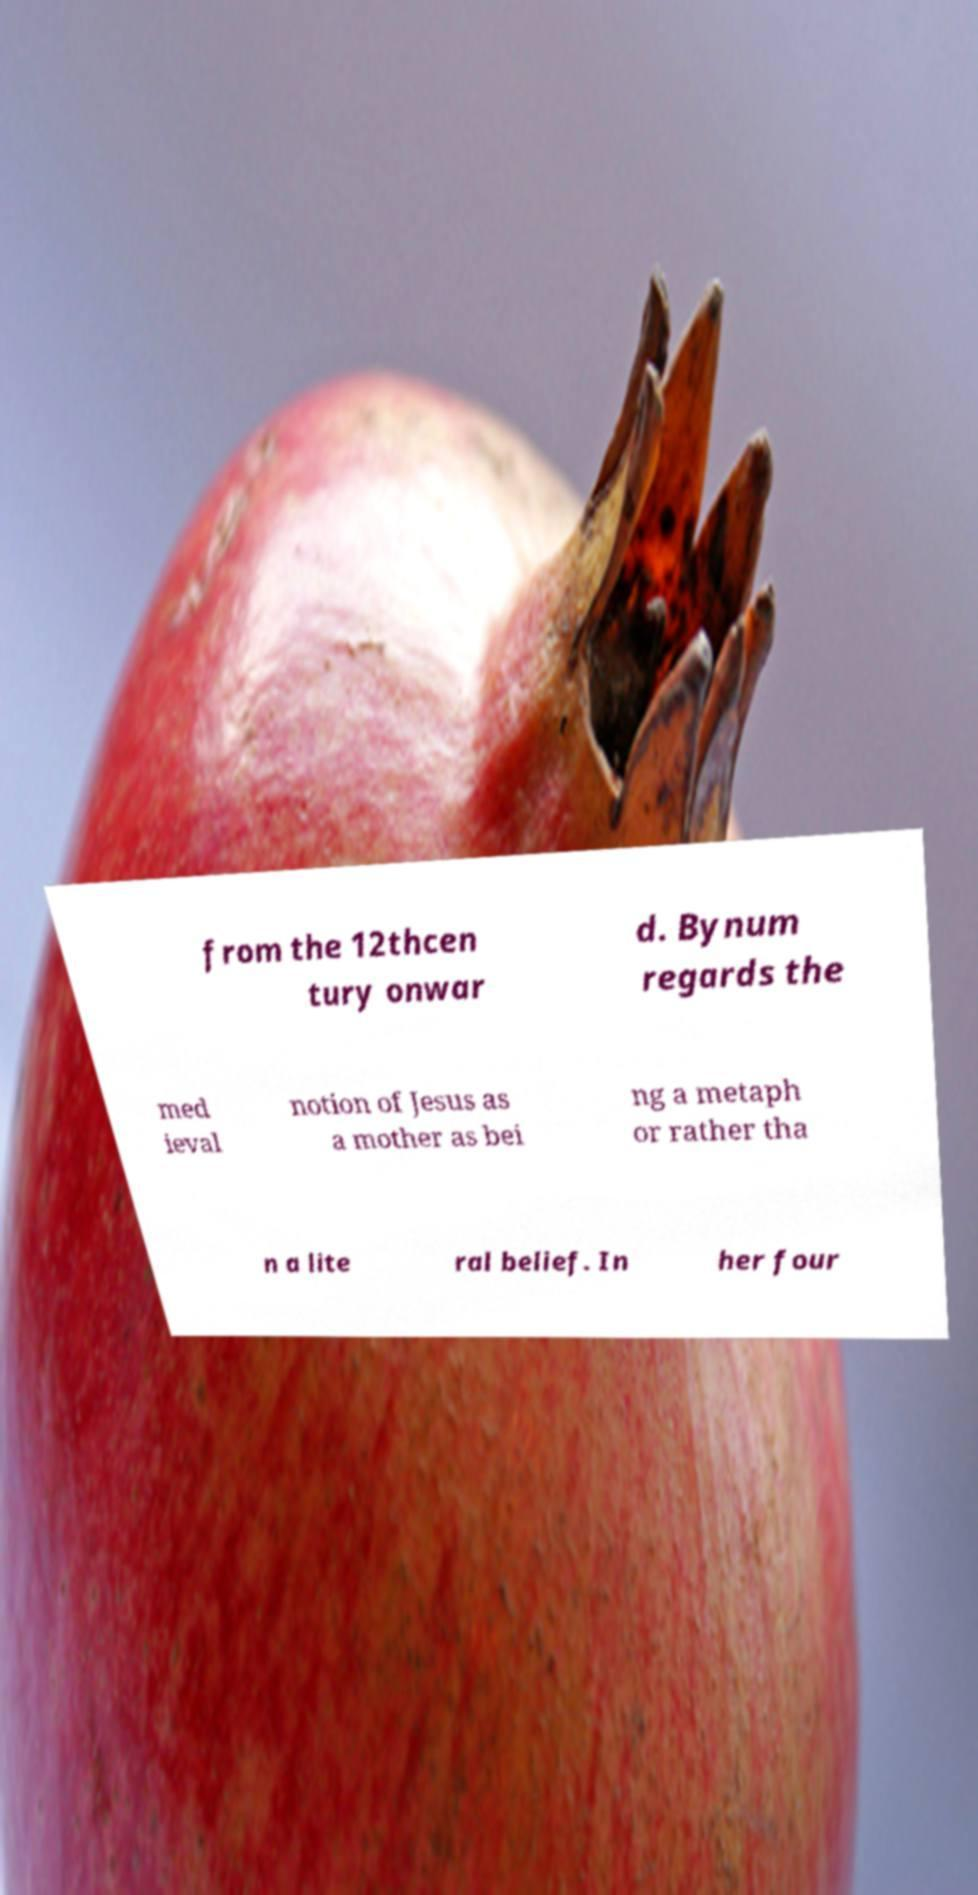There's text embedded in this image that I need extracted. Can you transcribe it verbatim? from the 12thcen tury onwar d. Bynum regards the med ieval notion of Jesus as a mother as bei ng a metaph or rather tha n a lite ral belief. In her four 